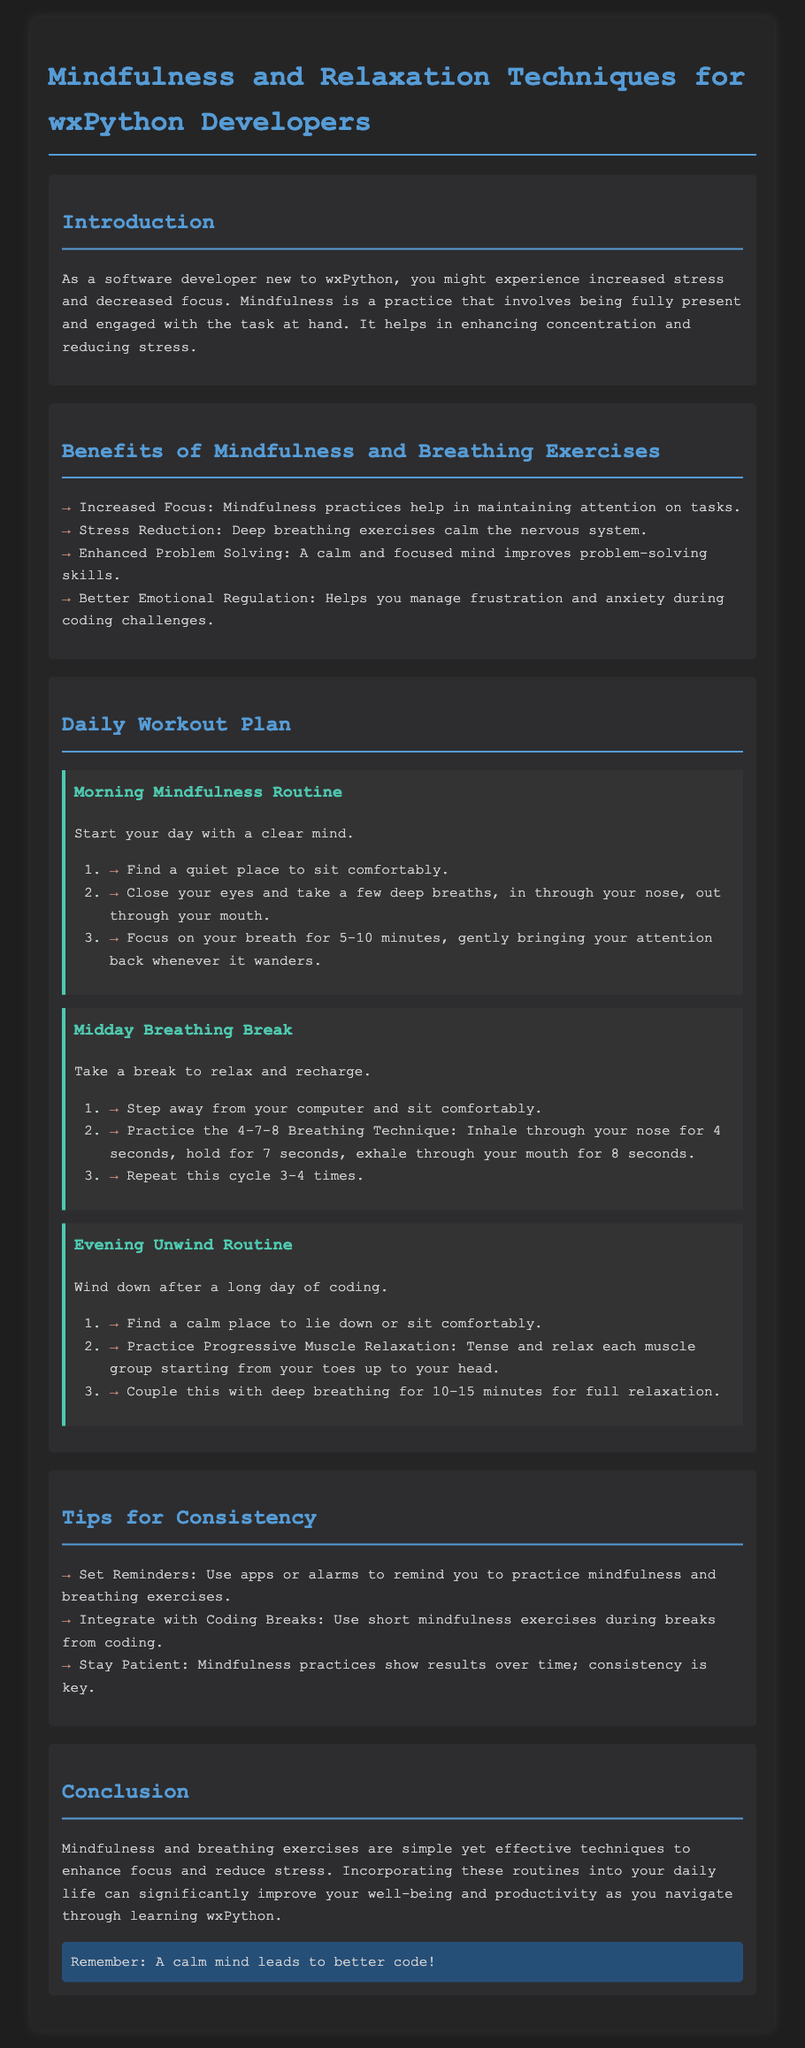what is the title of the document? The title of the document is specified in the `<title>` tag of the HTML, which is "Mindfulness Workout Plan for wxPython Developers."
Answer: Mindfulness Workout Plan for wxPython Developers what is the primary benefit of mindfulness mentioned? The primary benefit listed in the document is identified under "Benefits of Mindfulness and Breathing Exercises," focusing on how mindfulness helps in enhancing concentration and reducing stress.
Answer: Increased Focus what technique is practiced during the Midday Breathing Break? The document specifies the technique practiced during the Midday Breathing Break as the 4-7-8 Breathing Technique.
Answer: 4-7-8 Breathing Technique how long should the Morning Mindfulness Routine last? The document advises focusing on your breath for 5-10 minutes, indicating the expected duration of the Morning Mindfulness Routine.
Answer: 5-10 minutes how many times should you repeat the breathing cycle in the Midday Breathing Break? The repeat count for the breathing cycle is explicitly stated in the workflow step, specifying that you should repeat it 3-4 times.
Answer: 3-4 times what should you do to maintain consistency with mindfulness practices? The document provides a specific tip for consistency, suggesting the use of apps or alarms to remind practices.
Answer: Set Reminders which relaxation technique is combined with deep breathing in the Evening Unwind Routine? The relaxation technique mentioned in conjunction with deep breathing is Progressive Muscle Relaxation, which involves tensing and relaxing muscles.
Answer: Progressive Muscle Relaxation what is the overall goal of the daily workout plan? The document summarizes that the overall goal of integrating these techniques is to enhance focus and reduce stress, serving wxPython developers effectively.
Answer: Enhance focus and reduce stress 